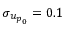<formula> <loc_0><loc_0><loc_500><loc_500>\sigma _ { { u _ { p } } _ { 0 } } = 0 . 1</formula> 